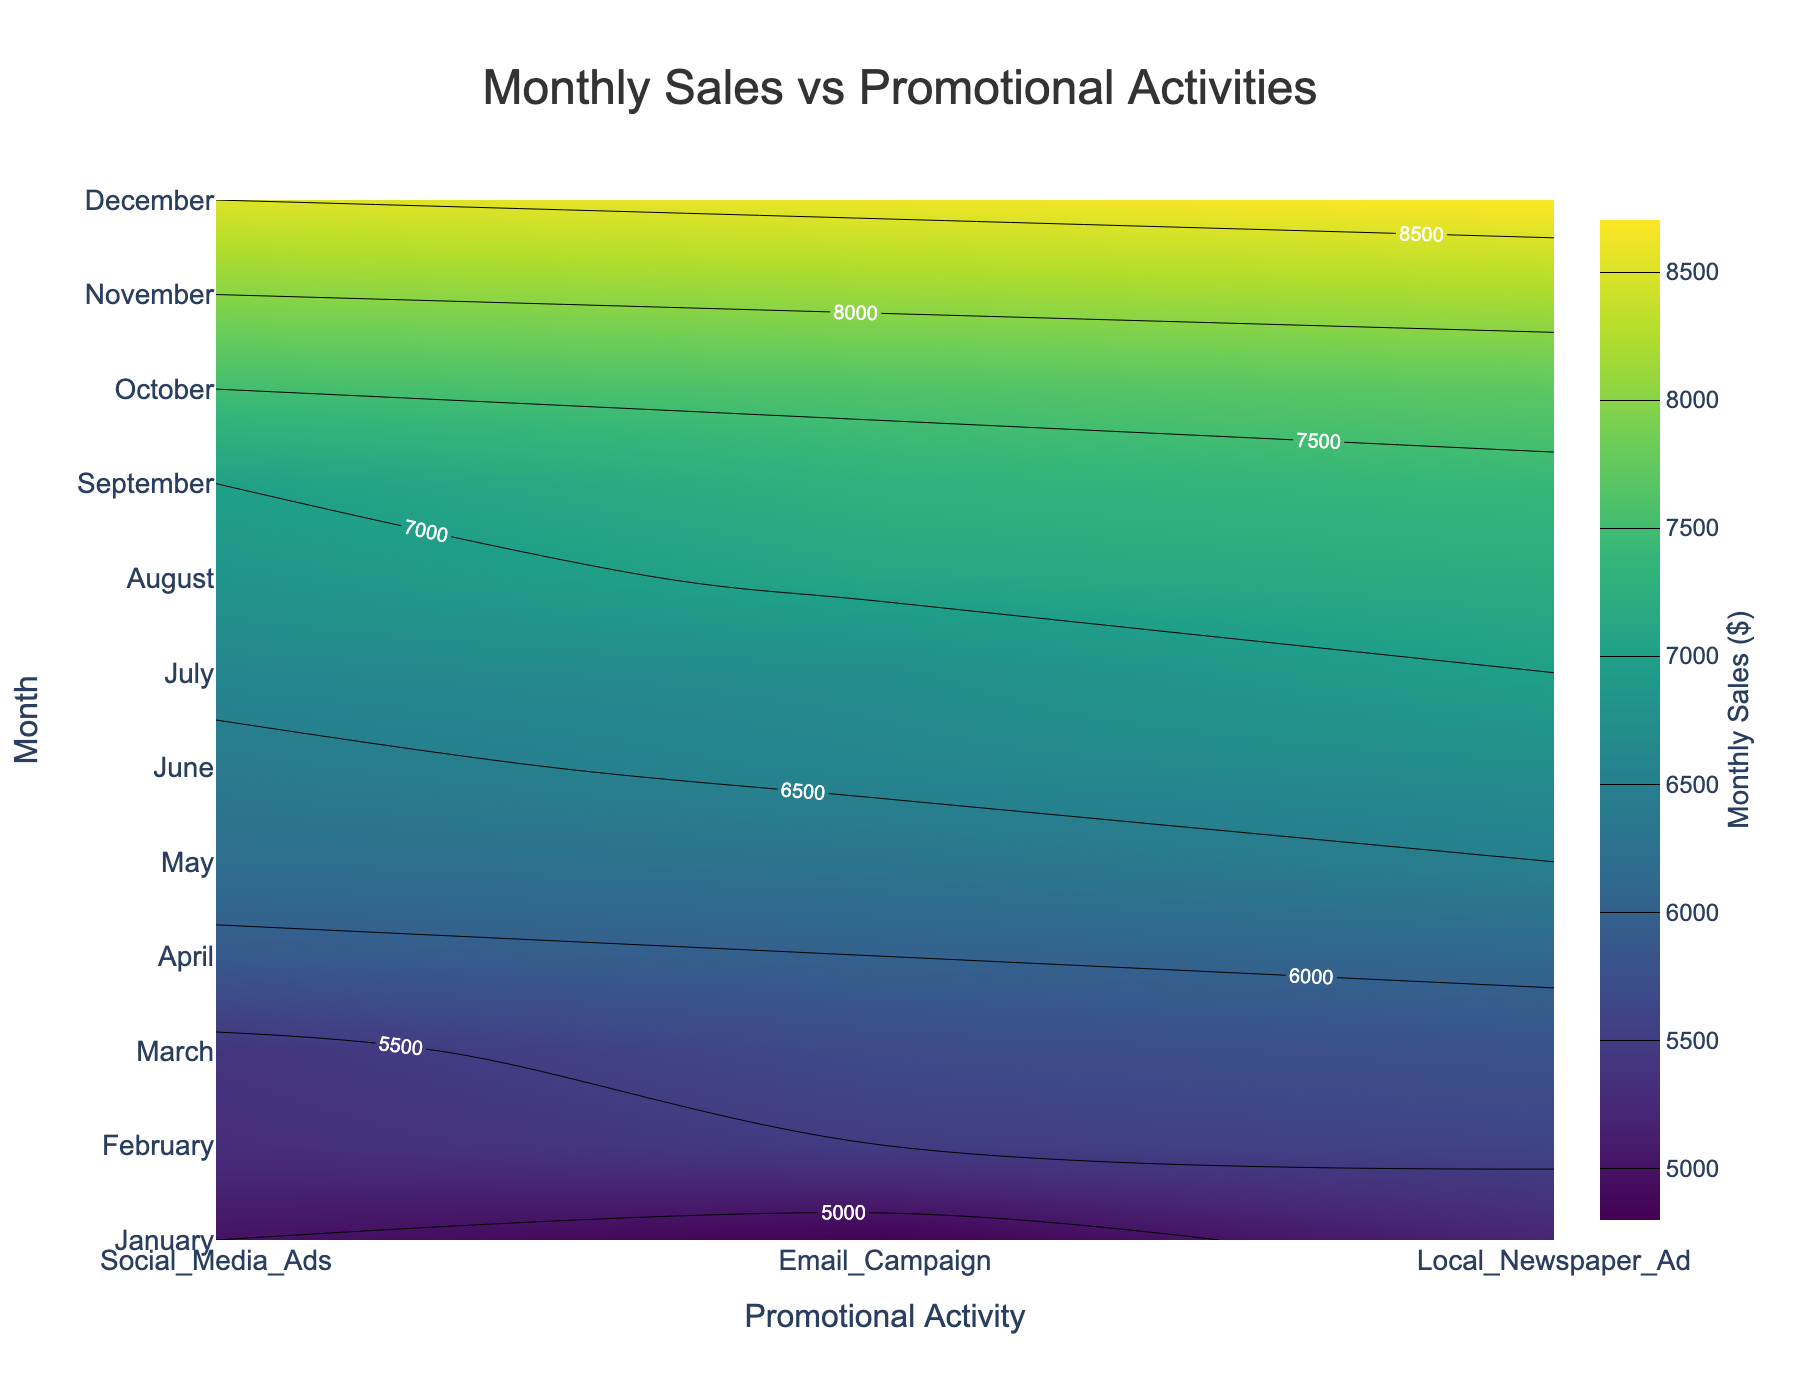What is the title of the plot? The title is usually found at the top of the plot, providing a summary of what the plot represents. In this case, it should be "Monthly Sales vs Promotional Activities".
Answer: Monthly Sales vs Promotional Activities What does the color scale represent in the plot? The color scale, usually displayed as a color bar, represents values in the data. In this plot, the color scale represents the Monthly Sales in dollars.
Answer: Monthly Sales in dollars Which promotional activity had the highest sales in January? To find this information, look at the January row across the different promotional activities and find the highest labeled contour value. The colors and labels indicate that Local Newspaper Ad had the highest sales.
Answer: Local Newspaper Ad What month had the highest overall sales for Email Campaigns? Check the contour labels or colors for each month in the Email Campaign column to find the highest value. The month with the darkest color or highest labeled value is December.
Answer: December By how much did the sales for Social Media Ads increase from January to December? Locate the contour labels or colors for Social Media Ads in both January and December. Subtract the January sales (5000) from the December sales (8500). The increase in sales can be calculated as 8500 - 5000.
Answer: 3500 Which promotional activity saw the most consistent increase in sales over the months? Assess the general trend of sales values for each promotional activity by examining the contours. Email Campaign and Local Newspaper Ad both show consistent increases, but Local Newspaper Ad starts from a higher base and shows a steady increase without much fluctuation.
Answer: Local Newspaper Ad In which month was the difference between Email Campaign and Social Media Ads the smallest? Compare the sales values for Email Campaign and Social Media Ads for each month. The smallest difference is found in July, both having 6700.
Answer: July What is the average sales for Local Newspaper Ad from January to December? To find the average, sum up the sales values for Local Newspaper Ad over all months and divide by the number of months (12). Calculating (5200 + 5600 + 5800 + 6100 + 6500 + 6700 + 7000 + 7200 + 7400 + 7700 + 8200 + 8700) / 12. The sum is 82100 and the average is 82100 / 12.
Answer: 6841.67 Which month shows the highest variation in sales between different promotional activities? To determine this, compare the difference between the highest and lowest sales values for each month. October shows the highest variation with the difference between Local Newspaper Ad (7700) and Social Media Ads (7500) being 200.
Answer: October 